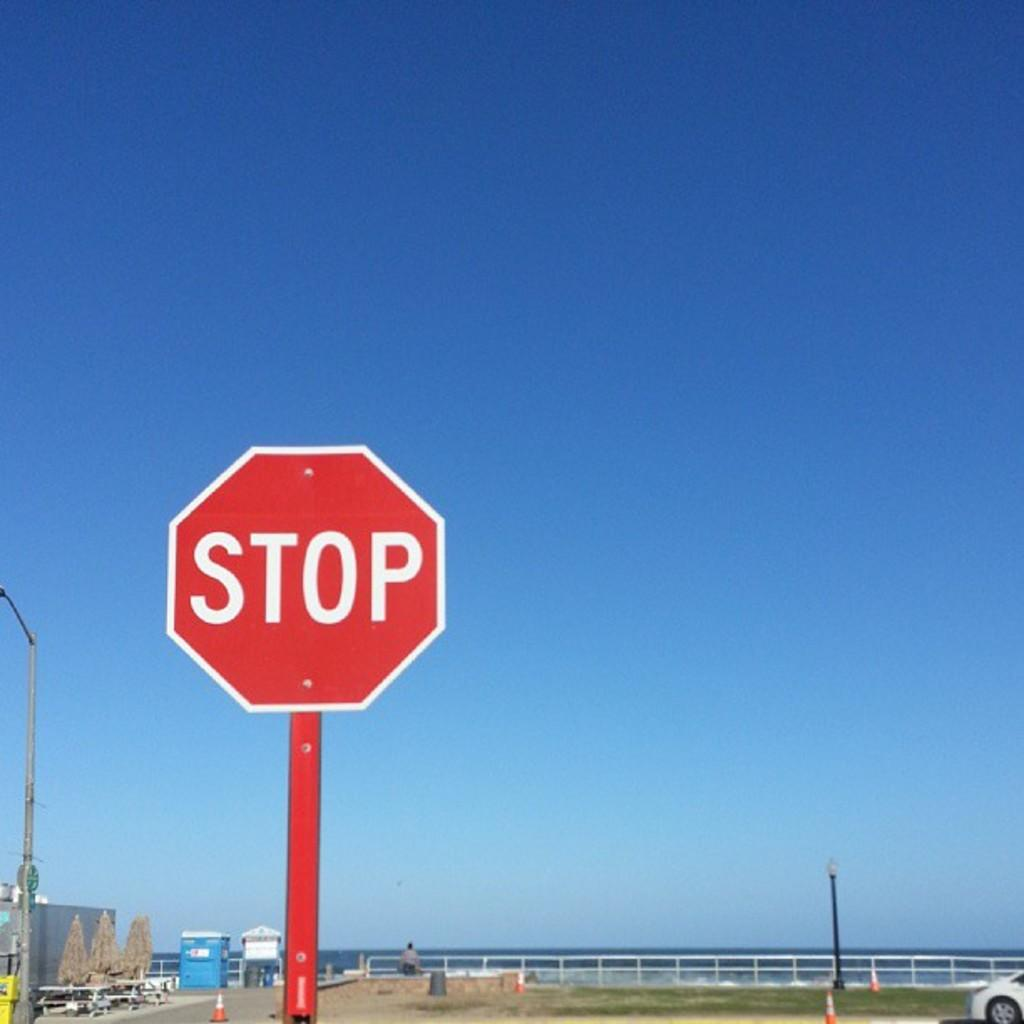<image>
Relay a brief, clear account of the picture shown. A stop sign is installed in front of a beach area. 